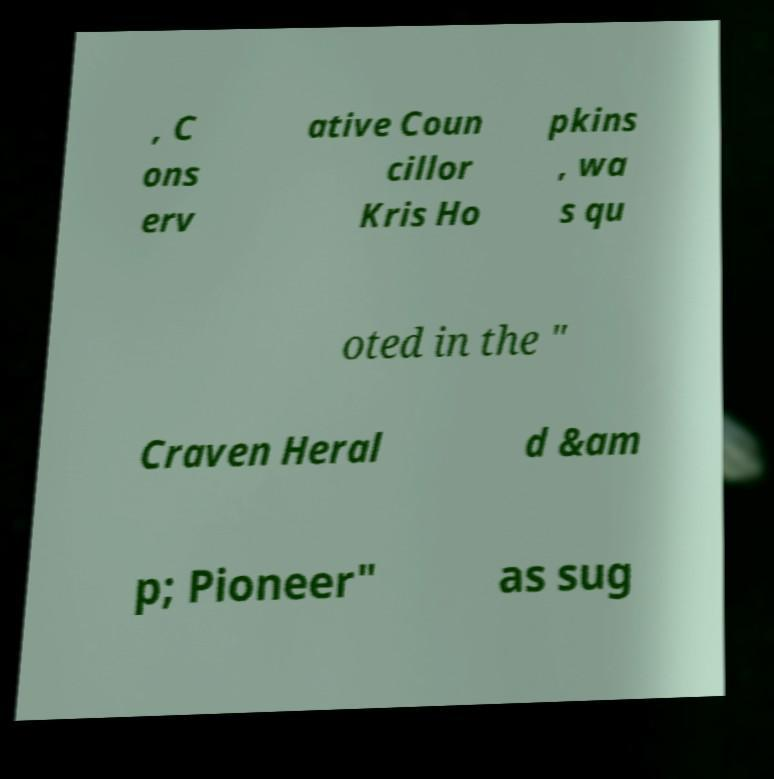Please read and relay the text visible in this image. What does it say? , C ons erv ative Coun cillor Kris Ho pkins , wa s qu oted in the " Craven Heral d &am p; Pioneer" as sug 